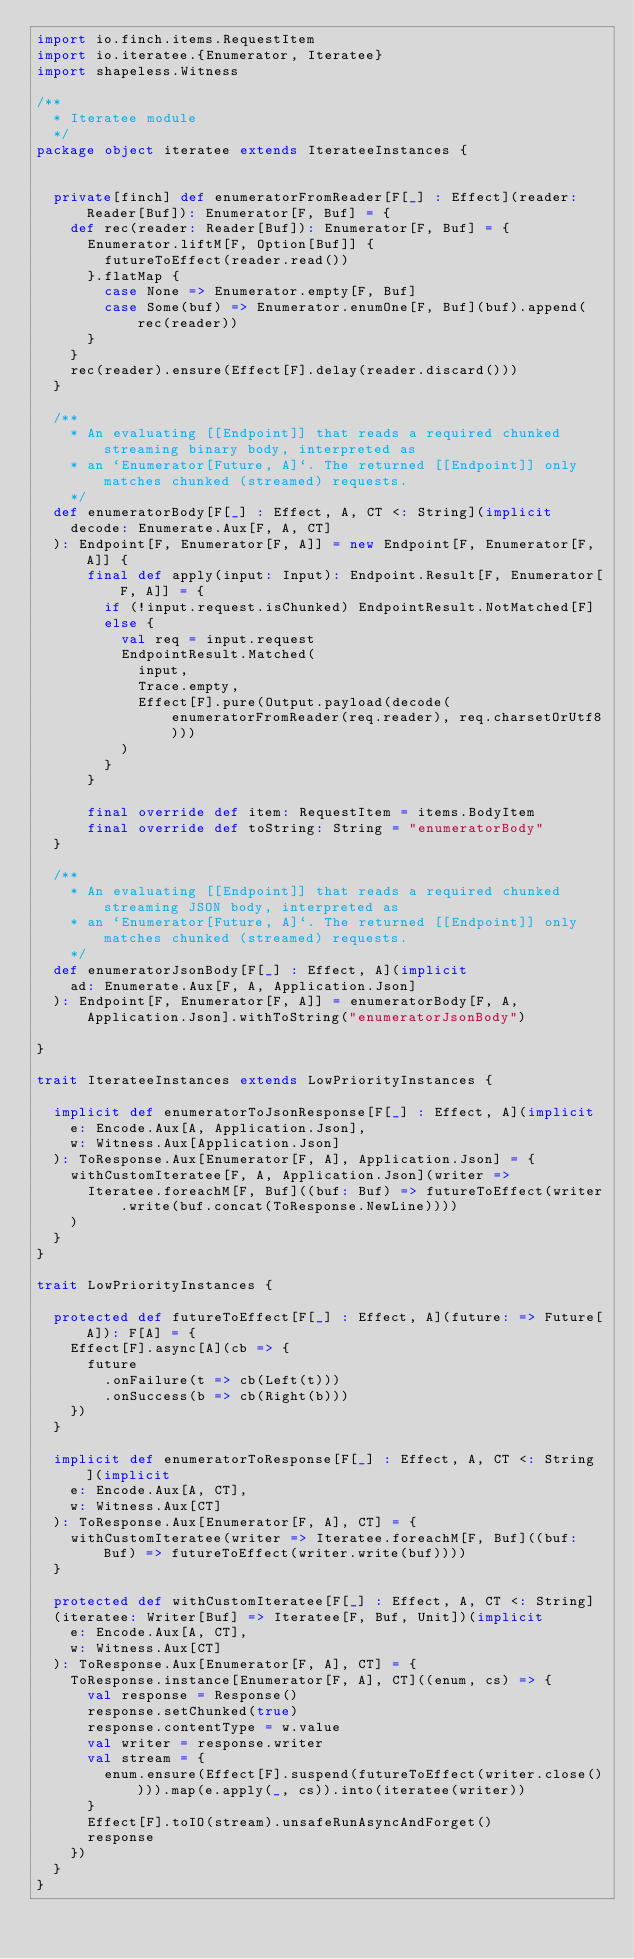Convert code to text. <code><loc_0><loc_0><loc_500><loc_500><_Scala_>import io.finch.items.RequestItem
import io.iteratee.{Enumerator, Iteratee}
import shapeless.Witness

/**
  * Iteratee module
  */
package object iteratee extends IterateeInstances {


  private[finch] def enumeratorFromReader[F[_] : Effect](reader: Reader[Buf]): Enumerator[F, Buf] = {
    def rec(reader: Reader[Buf]): Enumerator[F, Buf] = {
      Enumerator.liftM[F, Option[Buf]] {
        futureToEffect(reader.read())
      }.flatMap {
        case None => Enumerator.empty[F, Buf]
        case Some(buf) => Enumerator.enumOne[F, Buf](buf).append(rec(reader))
      }
    }
    rec(reader).ensure(Effect[F].delay(reader.discard()))
  }

  /**
    * An evaluating [[Endpoint]] that reads a required chunked streaming binary body, interpreted as
    * an `Enumerator[Future, A]`. The returned [[Endpoint]] only matches chunked (streamed) requests.
    */
  def enumeratorBody[F[_] : Effect, A, CT <: String](implicit
    decode: Enumerate.Aux[F, A, CT]
  ): Endpoint[F, Enumerator[F, A]] = new Endpoint[F, Enumerator[F, A]] {
      final def apply(input: Input): Endpoint.Result[F, Enumerator[F, A]] = {
        if (!input.request.isChunked) EndpointResult.NotMatched[F]
        else {
          val req = input.request
          EndpointResult.Matched(
            input,
            Trace.empty,
            Effect[F].pure(Output.payload(decode(enumeratorFromReader(req.reader), req.charsetOrUtf8)))
          )
        }
      }

      final override def item: RequestItem = items.BodyItem
      final override def toString: String = "enumeratorBody"
  }

  /**
    * An evaluating [[Endpoint]] that reads a required chunked streaming JSON body, interpreted as
    * an `Enumerator[Future, A]`. The returned [[Endpoint]] only matches chunked (streamed) requests.
    */
  def enumeratorJsonBody[F[_] : Effect, A](implicit
    ad: Enumerate.Aux[F, A, Application.Json]
  ): Endpoint[F, Enumerator[F, A]] = enumeratorBody[F, A, Application.Json].withToString("enumeratorJsonBody")

}

trait IterateeInstances extends LowPriorityInstances {

  implicit def enumeratorToJsonResponse[F[_] : Effect, A](implicit
    e: Encode.Aux[A, Application.Json],
    w: Witness.Aux[Application.Json]
  ): ToResponse.Aux[Enumerator[F, A], Application.Json] = {
    withCustomIteratee[F, A, Application.Json](writer =>
      Iteratee.foreachM[F, Buf]((buf: Buf) => futureToEffect(writer.write(buf.concat(ToResponse.NewLine))))
    )
  }
}

trait LowPriorityInstances {

  protected def futureToEffect[F[_] : Effect, A](future: => Future[A]): F[A] = {
    Effect[F].async[A](cb => {
      future
        .onFailure(t => cb(Left(t)))
        .onSuccess(b => cb(Right(b)))
    })
  }

  implicit def enumeratorToResponse[F[_] : Effect, A, CT <: String](implicit
    e: Encode.Aux[A, CT],
    w: Witness.Aux[CT]
  ): ToResponse.Aux[Enumerator[F, A], CT] = {
    withCustomIteratee(writer => Iteratee.foreachM[F, Buf]((buf: Buf) => futureToEffect(writer.write(buf))))
  }

  protected def withCustomIteratee[F[_] : Effect, A, CT <: String]
  (iteratee: Writer[Buf] => Iteratee[F, Buf, Unit])(implicit
    e: Encode.Aux[A, CT],
    w: Witness.Aux[CT]
  ): ToResponse.Aux[Enumerator[F, A], CT] = {
    ToResponse.instance[Enumerator[F, A], CT]((enum, cs) => {
      val response = Response()
      response.setChunked(true)
      response.contentType = w.value
      val writer = response.writer
      val stream = {
        enum.ensure(Effect[F].suspend(futureToEffect(writer.close()))).map(e.apply(_, cs)).into(iteratee(writer))
      }
      Effect[F].toIO(stream).unsafeRunAsyncAndForget()
      response
    })
  }
}
</code> 